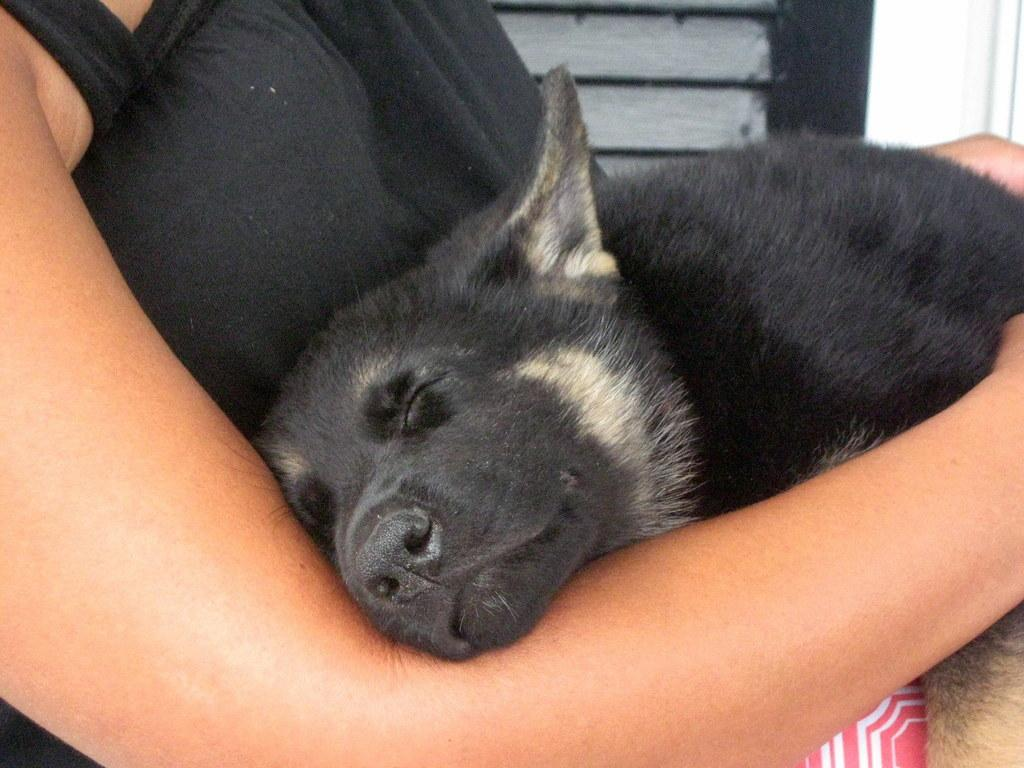What animal can be seen in the image? There is a dog in the image. What is the dog doing in the image? The dog is sleeping. Where is the dog located in the image? The dog is on a person's lap. What advice is the deer giving to the person in the image? There is no deer present in the image, so it is not possible to answer that question. 